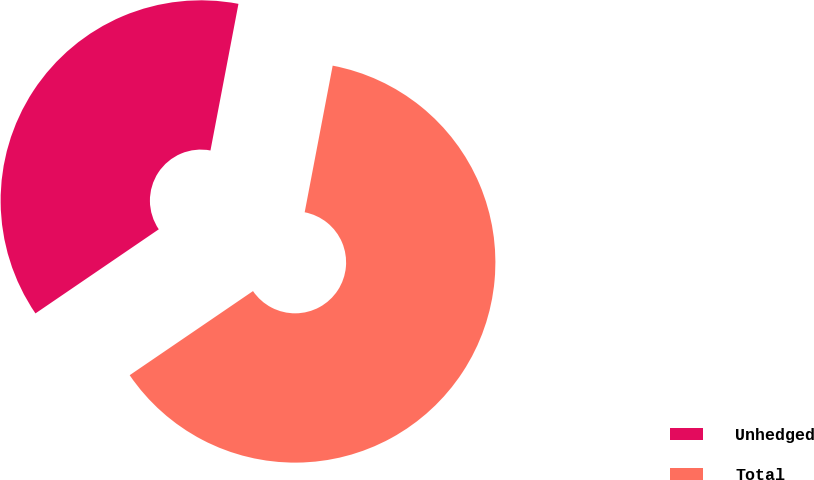Convert chart to OTSL. <chart><loc_0><loc_0><loc_500><loc_500><pie_chart><fcel>Unhedged<fcel>Total<nl><fcel>37.53%<fcel>62.47%<nl></chart> 